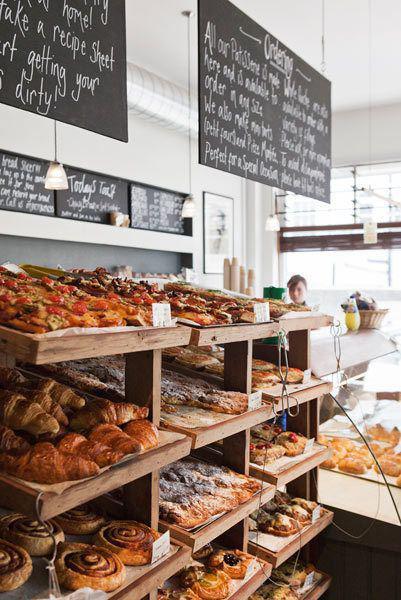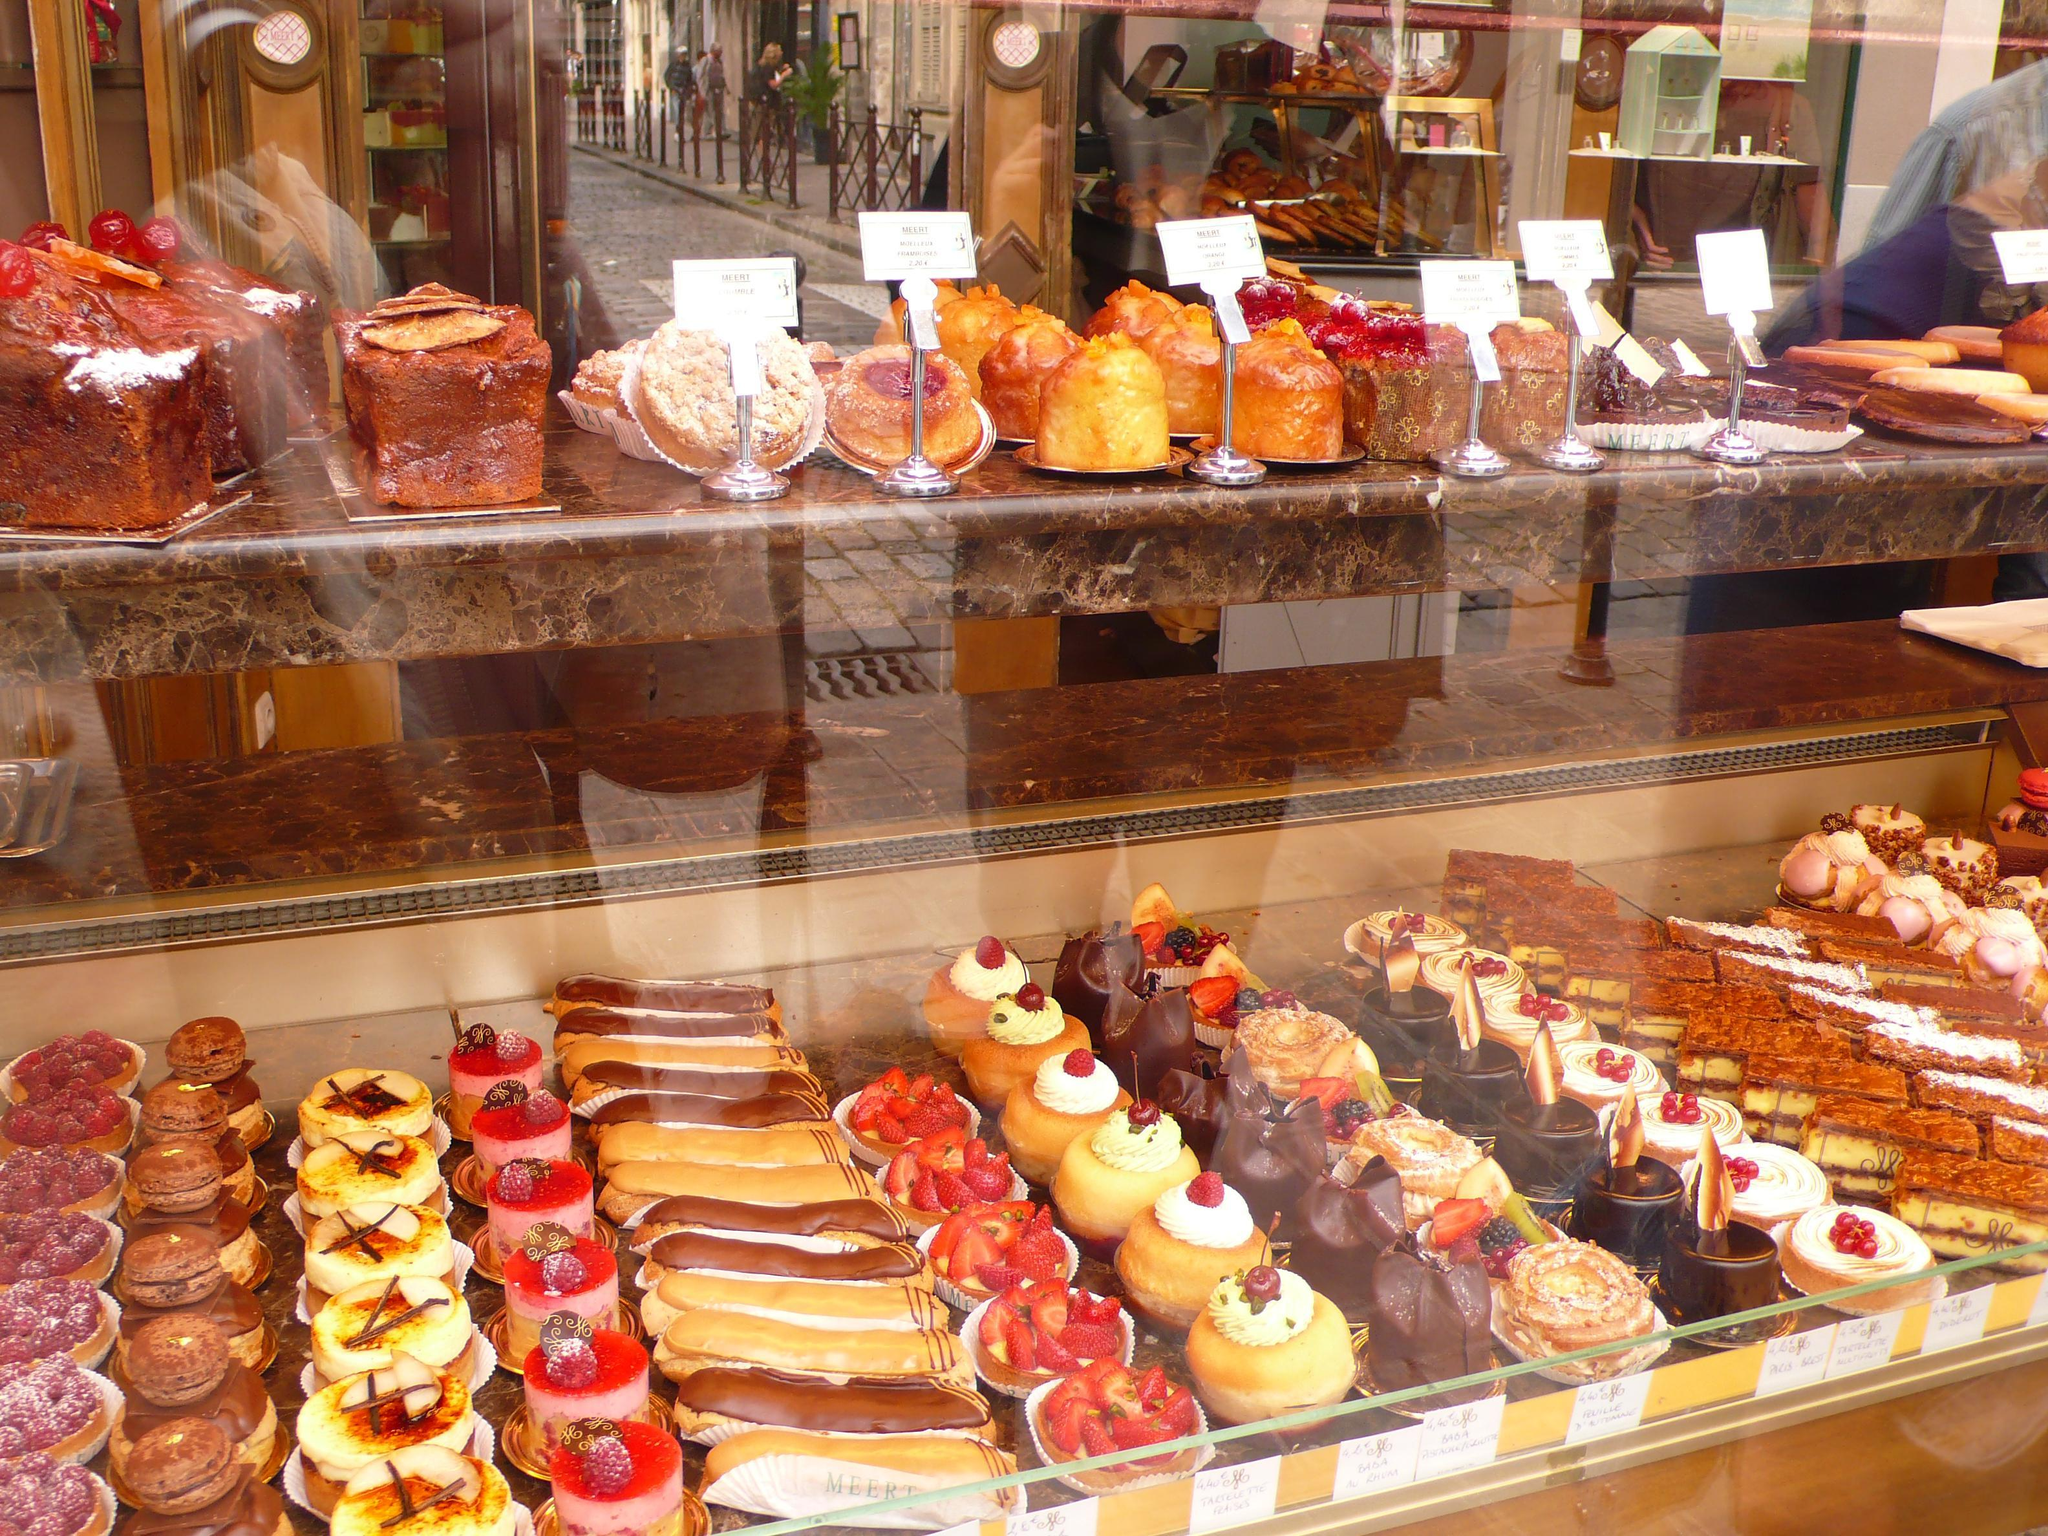The first image is the image on the left, the second image is the image on the right. Evaluate the accuracy of this statement regarding the images: "There is a shoppe entrance with a striped awning.". Is it true? Answer yes or no. No. 